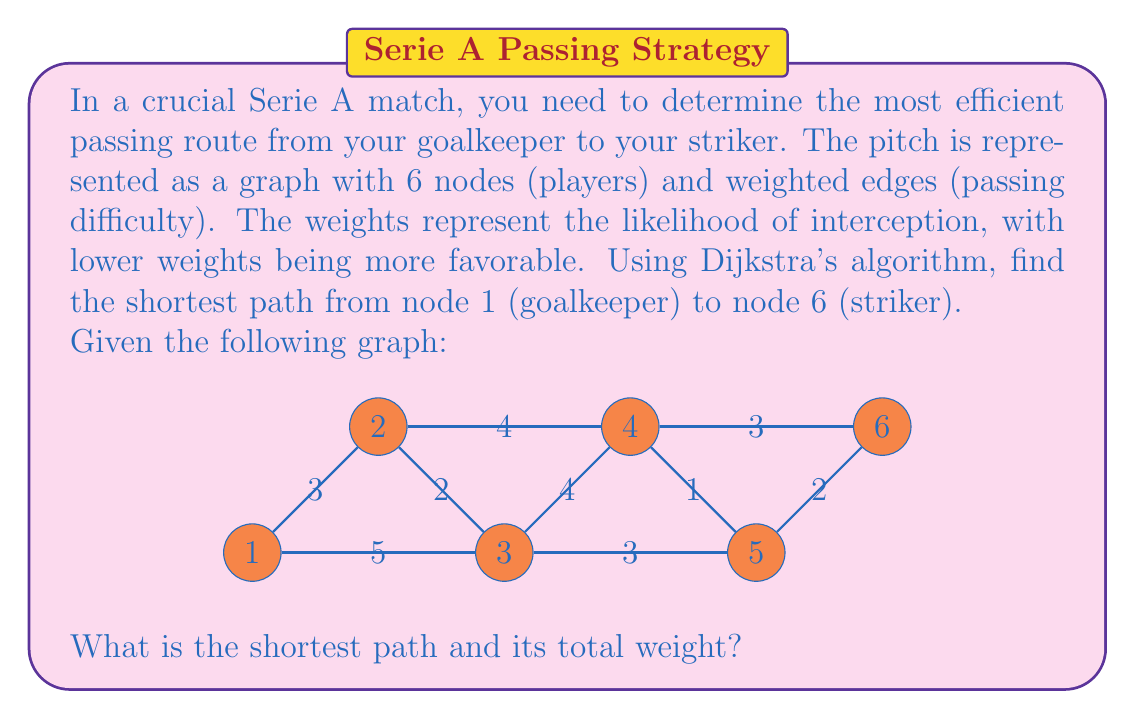Show me your answer to this math problem. To solve this problem, we'll use Dijkstra's algorithm to find the shortest path from node 1 to node 6. Let's go through the steps:

1) Initialize:
   - Distance to node 1 = 0
   - Distance to all other nodes = $\infty$
   - Set of unvisited nodes = {1, 2, 3, 4, 5, 6}

2) From node 1:
   - Update distances: 1->2 (3), 1->3 (5)
   - Select node 2 (shortest distance)

3) From node 2:
   - Update distances: 2->3 (2), 2->4 (4)
   - Select node 3 (shortest distance)

4) From node 3:
   - Update distances: 3->4 (4), 3->5 (3)
   - Select node 5 (shortest distance)

5) From node 5:
   - Update distance: 5->6 (2)
   - Select node 4 (next shortest distance)

6) From node 4:
   - Update distance: 4->6 (3)
   - Select node 6 (final node)

The shortest path is 1 -> 2 -> 3 -> 5 -> 6

The total weight of this path is:
$$ 3 + 2 + 3 + 2 = 10 $$
Answer: The shortest path is 1 -> 2 -> 3 -> 5 -> 6, with a total weight of 10. 